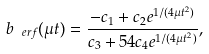<formula> <loc_0><loc_0><loc_500><loc_500>b _ { \ e r f } ( \mu t ) = \frac { - c _ { 1 } + c _ { 2 } e ^ { 1 / ( 4 \mu t ^ { 2 } ) } } { c _ { 3 } + 5 4 c _ { 4 } e ^ { 1 / ( 4 \mu t ^ { 2 } ) } } ,</formula> 